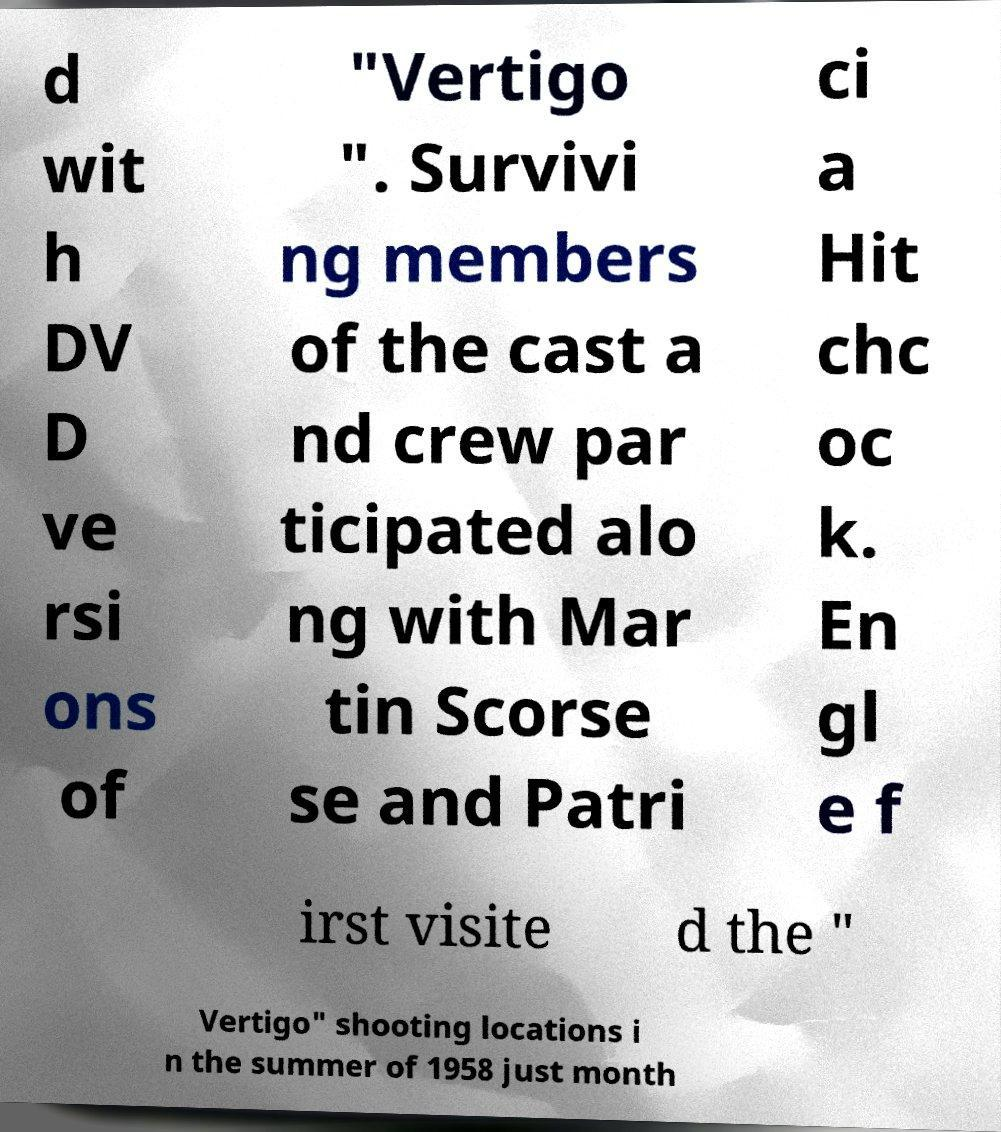For documentation purposes, I need the text within this image transcribed. Could you provide that? d wit h DV D ve rsi ons of "Vertigo ". Survivi ng members of the cast a nd crew par ticipated alo ng with Mar tin Scorse se and Patri ci a Hit chc oc k. En gl e f irst visite d the " Vertigo" shooting locations i n the summer of 1958 just month 